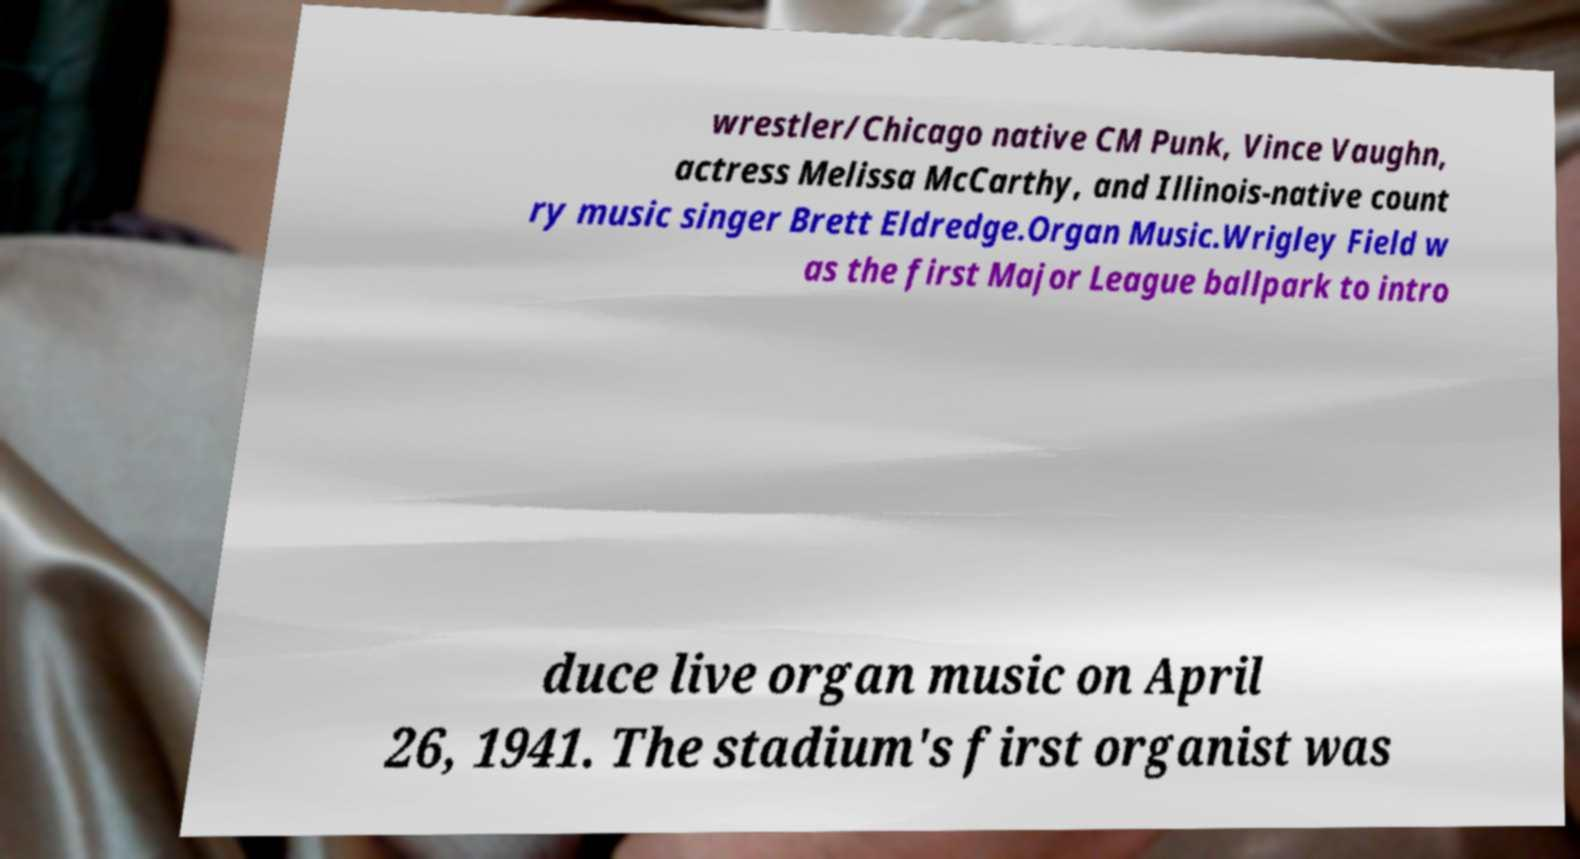Could you extract and type out the text from this image? wrestler/Chicago native CM Punk, Vince Vaughn, actress Melissa McCarthy, and Illinois-native count ry music singer Brett Eldredge.Organ Music.Wrigley Field w as the first Major League ballpark to intro duce live organ music on April 26, 1941. The stadium's first organist was 